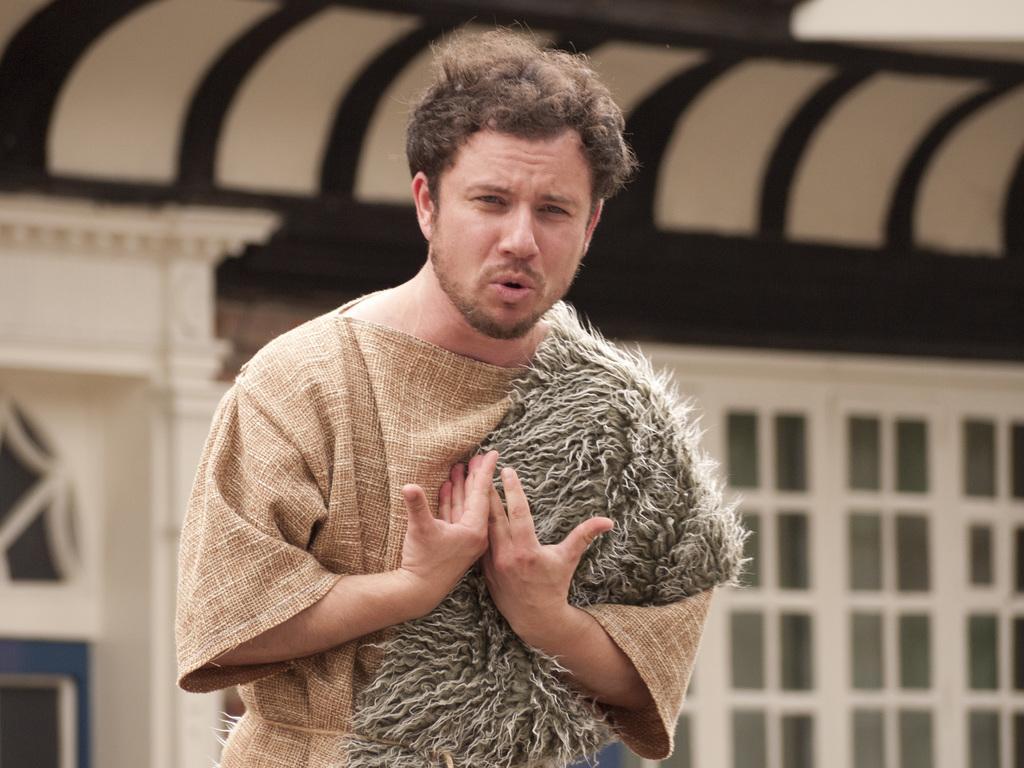In one or two sentences, can you explain what this image depicts? In this image, there is a person on the blur background. This person is wearing clothes. 